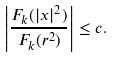<formula> <loc_0><loc_0><loc_500><loc_500>\left | \frac { F _ { k } ( | x | ^ { 2 } ) } { F _ { k } ( r ^ { 2 } ) } \right | \leq c .</formula> 